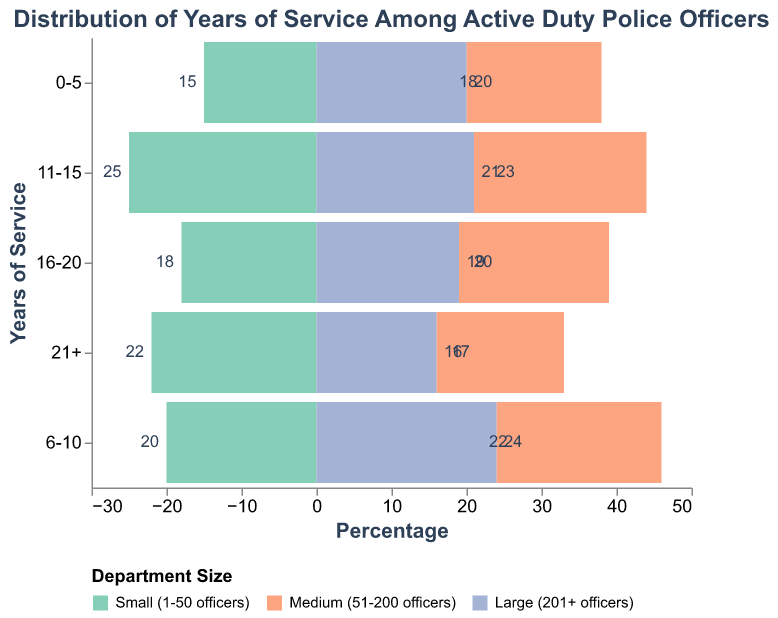What is the title of the figure? The title of the figure is located at the top, bolded, and larger in size compared to other text elements. It reads "Distribution of Years of Service Among Active Duty Police Officers."
Answer: Distribution of Years of Service Among Active Duty Police Officers What percentage of officers in small departments have 16-20 years of service? Locate the bar representing small departments in the years of service "16-20" category. The percentage displayed within or near the bar is 18%.
Answer: 18% Which department size has the highest percentage of officers with 6-10 years of service? Compare the bars for the 6-10 years of service category across all department sizes. The department size with the tallest bar (highest percentage) in this category is "Large (201+ officers)" with 24%.
Answer: Large (201+ officers) How do the percentages of officers with 21+ years of service compare between small and medium departments? Find the bars representing small and medium departments in the "21+" category. Small departments have a percentage of 22%, while medium departments have a percentage of 17%. By comparing, small departments have 5% more officers with 21+ years of service than medium departments.
Answer: Small departments have 5% more What is the total percentage of officers with 11-15 years of service in all department sizes? Sum the percentages for the 11-15 years of service category across all department sizes: 25% (small) + 23% (medium) + 21% (large) = 69%.
Answer: 69% Which department size shows the least variation in the distribution of percentages across different years of service? Evaluate the spread of percentages within each department size. The medium department has values of 18%, 22%, 23%, 20%, and 17%, showing relatively balanced distribution without extreme high or low percentages compared to small and large departments.
Answer: Medium (51-200 officers) For the 0-5 years of service category, which department size has the closest percentage to the overall average for this category? First, calculate the average percentage for the 0-5 years of service category: (15% (small) + 18% (medium) + 20% (large))/3 = 17.67%. Then, compare each department's percentage to see which is closest to 17.67%. The medium department has 18%, which is closest.
Answer: Medium (51-200 officers) What is the difference in the percentage of officers with 6-10 years of service between medium and large departments? Find the bars for 6-10 years of service in medium and large departments. Medium departments have 22%, and large departments have 24%. The difference is 24% - 22% = 2%.
Answer: 2% Which years of service category has the highest percentage of officers in small departments? Identify the highest bar for the small department across all years of service categories. The 11-15 years of service category has the highest at 25%.
Answer: 11-15 In large departments, what percentage of officers have more than 10 years of service? Add the percentages for the 11-15, 16-20, and 21+ categories in large departments: 21% + 19% + 16% = 56%.
Answer: 56% 